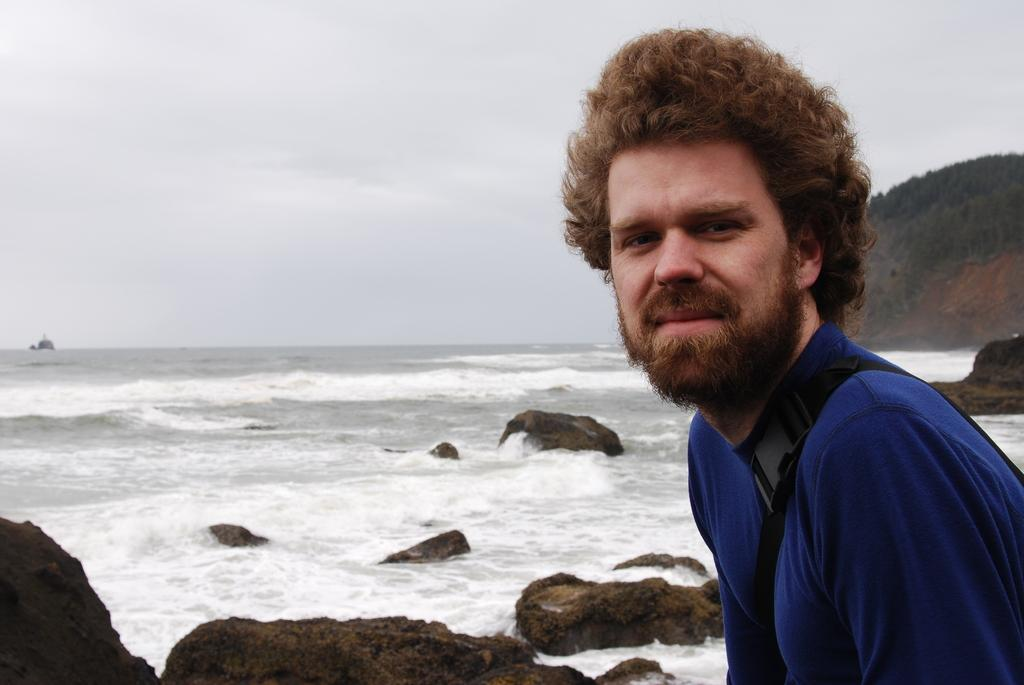Who is present in the image? There is a man in the image. What is the man wearing? The man is wearing a blue T-shirt. Where is the man located in the image? The man is on the right side of the image. What type of natural elements can be seen in the image? There are rocks and water visible in the image. What is visible in the background of the image? There is a hill and a cloudy sky visible in the background of the image. What type of prose is the man reciting in the image? There is no indication in the image that the man is reciting any prose. Can you tell me how many wishes are granted to the man in the image? There is no mention of wishes or any magical elements in the image. 